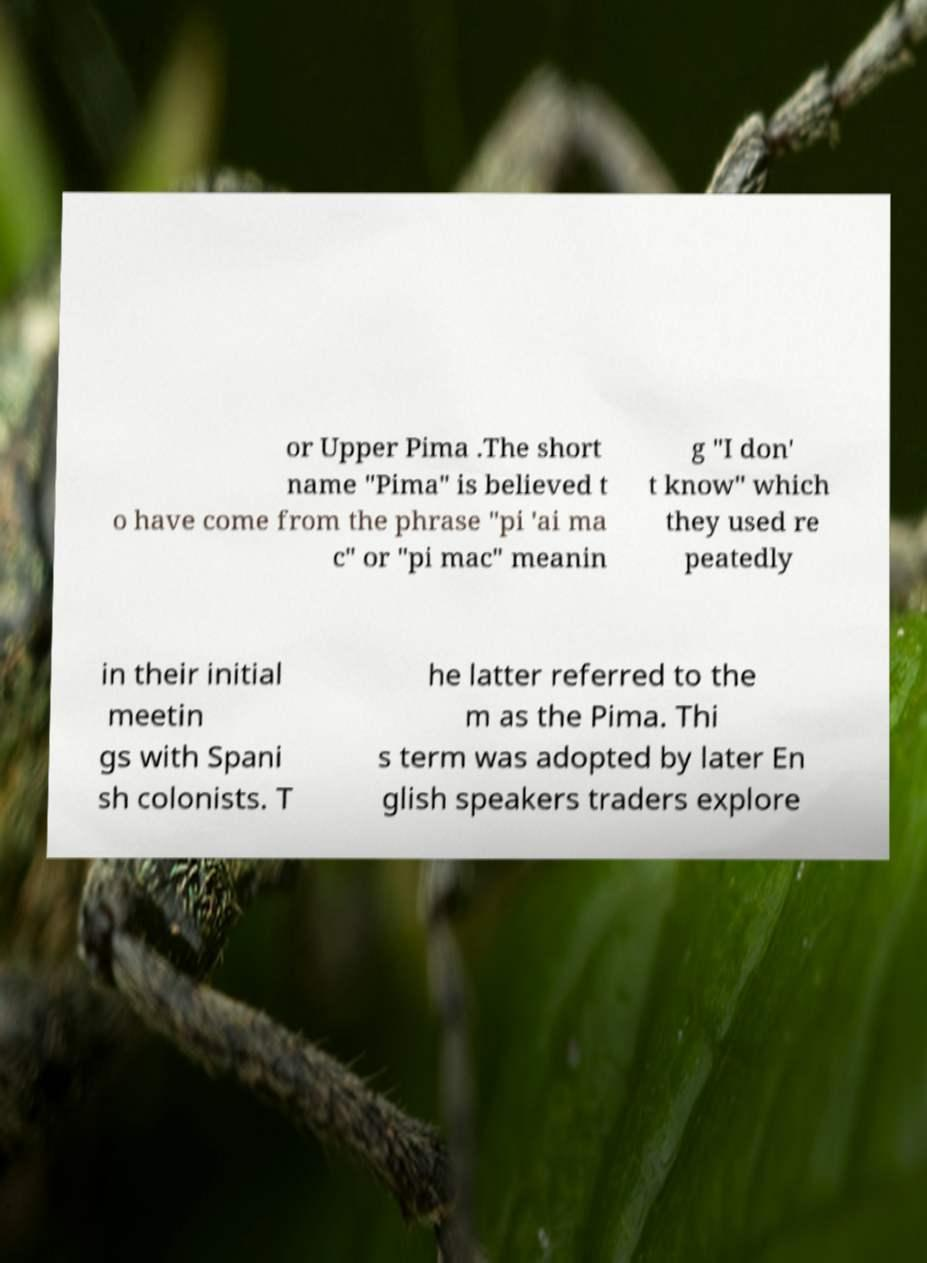For documentation purposes, I need the text within this image transcribed. Could you provide that? or Upper Pima .The short name "Pima" is believed t o have come from the phrase "pi 'ai ma c" or "pi mac" meanin g "I don' t know" which they used re peatedly in their initial meetin gs with Spani sh colonists. T he latter referred to the m as the Pima. Thi s term was adopted by later En glish speakers traders explore 